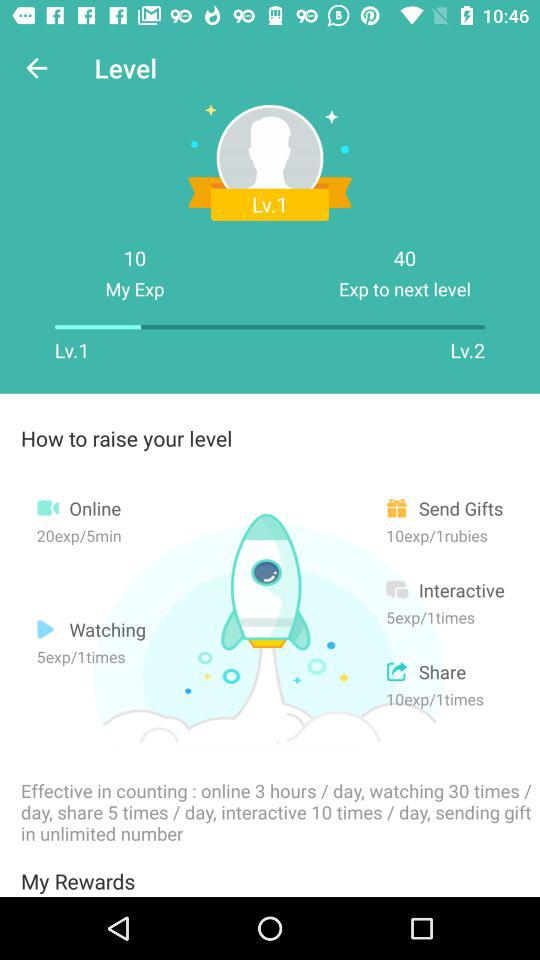What are the required experience points to reach level 2? The required experience points are 40. 